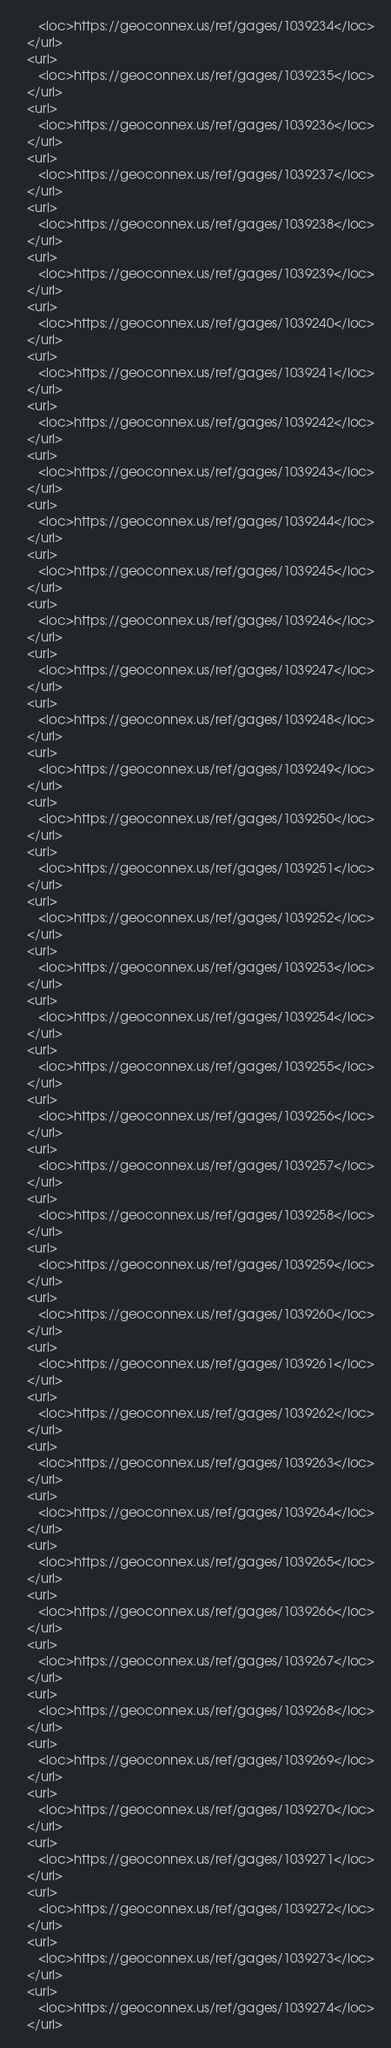Convert code to text. <code><loc_0><loc_0><loc_500><loc_500><_XML_>      <loc>https://geoconnex.us/ref/gages/1039234</loc>
   </url>
   <url>
      <loc>https://geoconnex.us/ref/gages/1039235</loc>
   </url>
   <url>
      <loc>https://geoconnex.us/ref/gages/1039236</loc>
   </url>
   <url>
      <loc>https://geoconnex.us/ref/gages/1039237</loc>
   </url>
   <url>
      <loc>https://geoconnex.us/ref/gages/1039238</loc>
   </url>
   <url>
      <loc>https://geoconnex.us/ref/gages/1039239</loc>
   </url>
   <url>
      <loc>https://geoconnex.us/ref/gages/1039240</loc>
   </url>
   <url>
      <loc>https://geoconnex.us/ref/gages/1039241</loc>
   </url>
   <url>
      <loc>https://geoconnex.us/ref/gages/1039242</loc>
   </url>
   <url>
      <loc>https://geoconnex.us/ref/gages/1039243</loc>
   </url>
   <url>
      <loc>https://geoconnex.us/ref/gages/1039244</loc>
   </url>
   <url>
      <loc>https://geoconnex.us/ref/gages/1039245</loc>
   </url>
   <url>
      <loc>https://geoconnex.us/ref/gages/1039246</loc>
   </url>
   <url>
      <loc>https://geoconnex.us/ref/gages/1039247</loc>
   </url>
   <url>
      <loc>https://geoconnex.us/ref/gages/1039248</loc>
   </url>
   <url>
      <loc>https://geoconnex.us/ref/gages/1039249</loc>
   </url>
   <url>
      <loc>https://geoconnex.us/ref/gages/1039250</loc>
   </url>
   <url>
      <loc>https://geoconnex.us/ref/gages/1039251</loc>
   </url>
   <url>
      <loc>https://geoconnex.us/ref/gages/1039252</loc>
   </url>
   <url>
      <loc>https://geoconnex.us/ref/gages/1039253</loc>
   </url>
   <url>
      <loc>https://geoconnex.us/ref/gages/1039254</loc>
   </url>
   <url>
      <loc>https://geoconnex.us/ref/gages/1039255</loc>
   </url>
   <url>
      <loc>https://geoconnex.us/ref/gages/1039256</loc>
   </url>
   <url>
      <loc>https://geoconnex.us/ref/gages/1039257</loc>
   </url>
   <url>
      <loc>https://geoconnex.us/ref/gages/1039258</loc>
   </url>
   <url>
      <loc>https://geoconnex.us/ref/gages/1039259</loc>
   </url>
   <url>
      <loc>https://geoconnex.us/ref/gages/1039260</loc>
   </url>
   <url>
      <loc>https://geoconnex.us/ref/gages/1039261</loc>
   </url>
   <url>
      <loc>https://geoconnex.us/ref/gages/1039262</loc>
   </url>
   <url>
      <loc>https://geoconnex.us/ref/gages/1039263</loc>
   </url>
   <url>
      <loc>https://geoconnex.us/ref/gages/1039264</loc>
   </url>
   <url>
      <loc>https://geoconnex.us/ref/gages/1039265</loc>
   </url>
   <url>
      <loc>https://geoconnex.us/ref/gages/1039266</loc>
   </url>
   <url>
      <loc>https://geoconnex.us/ref/gages/1039267</loc>
   </url>
   <url>
      <loc>https://geoconnex.us/ref/gages/1039268</loc>
   </url>
   <url>
      <loc>https://geoconnex.us/ref/gages/1039269</loc>
   </url>
   <url>
      <loc>https://geoconnex.us/ref/gages/1039270</loc>
   </url>
   <url>
      <loc>https://geoconnex.us/ref/gages/1039271</loc>
   </url>
   <url>
      <loc>https://geoconnex.us/ref/gages/1039272</loc>
   </url>
   <url>
      <loc>https://geoconnex.us/ref/gages/1039273</loc>
   </url>
   <url>
      <loc>https://geoconnex.us/ref/gages/1039274</loc>
   </url></code> 